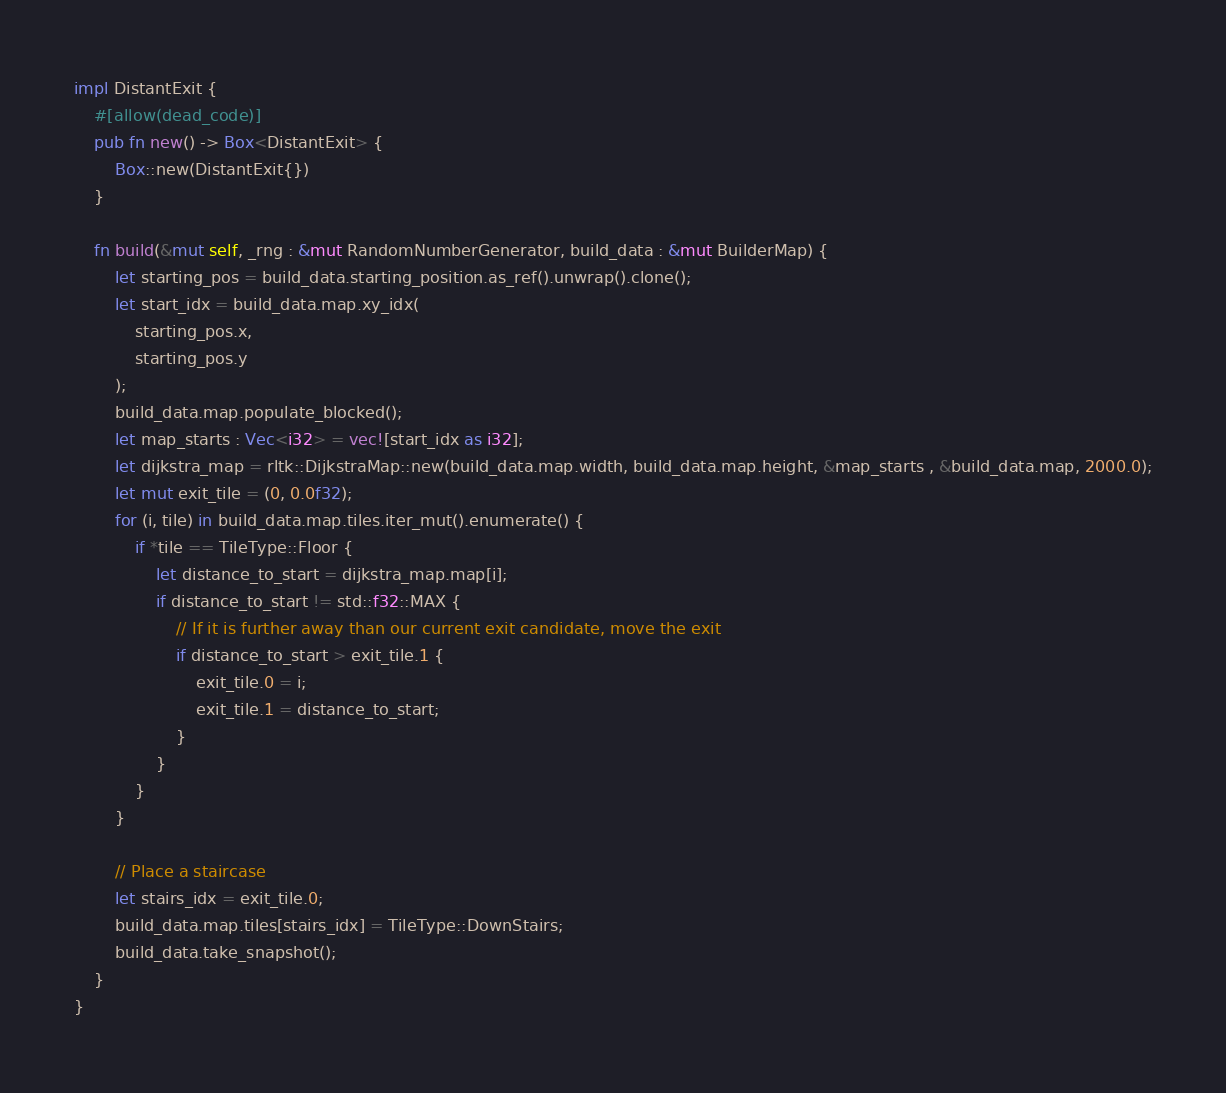Convert code to text. <code><loc_0><loc_0><loc_500><loc_500><_Rust_>
impl DistantExit {
    #[allow(dead_code)]
    pub fn new() -> Box<DistantExit> {
        Box::new(DistantExit{})
    }

    fn build(&mut self, _rng : &mut RandomNumberGenerator, build_data : &mut BuilderMap) {
        let starting_pos = build_data.starting_position.as_ref().unwrap().clone();
        let start_idx = build_data.map.xy_idx(
            starting_pos.x,
            starting_pos.y
        );
        build_data.map.populate_blocked();
        let map_starts : Vec<i32> = vec![start_idx as i32];
        let dijkstra_map = rltk::DijkstraMap::new(build_data.map.width, build_data.map.height, &map_starts , &build_data.map, 2000.0);
        let mut exit_tile = (0, 0.0f32);
        for (i, tile) in build_data.map.tiles.iter_mut().enumerate() {
            if *tile == TileType::Floor {
                let distance_to_start = dijkstra_map.map[i];
                if distance_to_start != std::f32::MAX {
                    // If it is further away than our current exit candidate, move the exit
                    if distance_to_start > exit_tile.1 {
                        exit_tile.0 = i;
                        exit_tile.1 = distance_to_start;
                    }
                }
            }
        }

        // Place a staircase
        let stairs_idx = exit_tile.0;
        build_data.map.tiles[stairs_idx] = TileType::DownStairs;
        build_data.take_snapshot();
    }
}
</code> 